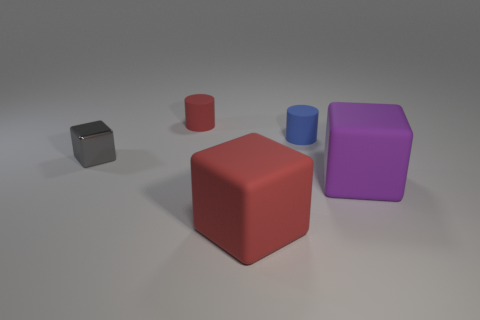Is the number of small red rubber things that are on the right side of the tiny red thing the same as the number of small red rubber objects?
Your answer should be very brief. No. What number of purple cubes have the same material as the tiny blue cylinder?
Offer a terse response. 1. What color is the other cylinder that is the same material as the tiny red cylinder?
Your answer should be very brief. Blue. Does the purple thing have the same size as the red thing in front of the small gray object?
Give a very brief answer. Yes. The tiny blue thing is what shape?
Provide a short and direct response. Cylinder. How many small metallic objects have the same color as the tiny cube?
Offer a very short reply. 0. The other rubber thing that is the same shape as the blue rubber thing is what color?
Your response must be concise. Red. How many tiny gray things are to the right of the cylinder to the left of the tiny blue cylinder?
Your answer should be compact. 0. How many cubes are either large yellow objects or purple things?
Give a very brief answer. 1. Are there any green cylinders?
Provide a succinct answer. No. 